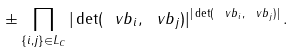Convert formula to latex. <formula><loc_0><loc_0><loc_500><loc_500>\pm \prod _ { \{ i , j \} \in L _ { C } } | \det ( \ v b _ { i } , \ v b _ { j } ) | ^ { | \det ( \ v b _ { i } , \ v b _ { j } ) | } \, .</formula> 